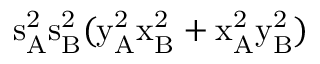Convert formula to latex. <formula><loc_0><loc_0><loc_500><loc_500>s _ { A } ^ { 2 } \mathrm { s _ { B } ^ { 2 } ( \mathrm { y _ { A } ^ { 2 } \mathrm { x _ { B } ^ { 2 } + \mathrm { x _ { A } ^ { 2 } \mathrm { y _ { B } ^ { 2 } ) } } } } }</formula> 